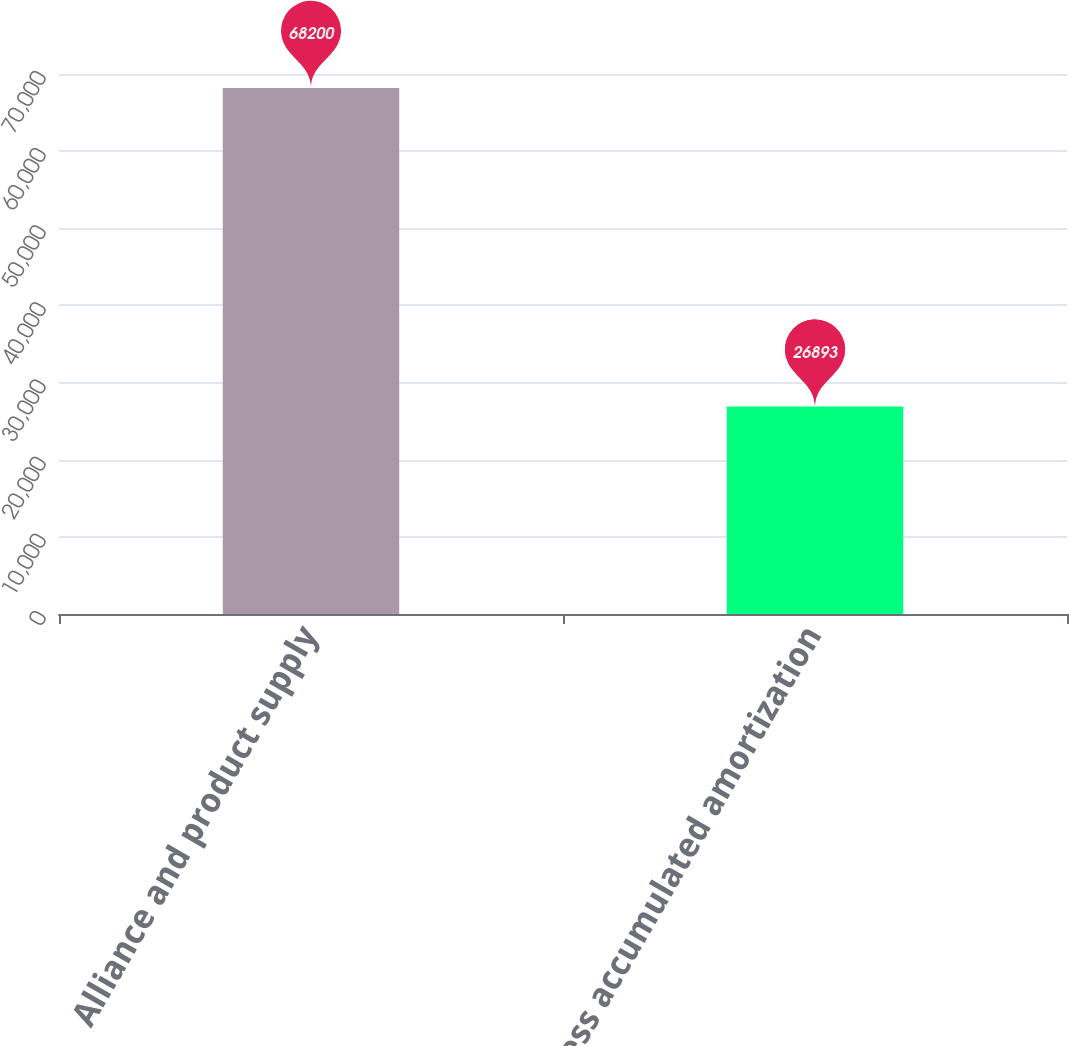<chart> <loc_0><loc_0><loc_500><loc_500><bar_chart><fcel>Alliance and product supply<fcel>Less accumulated amortization<nl><fcel>68200<fcel>26893<nl></chart> 